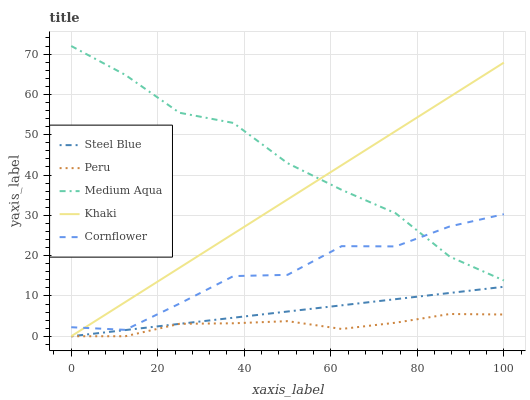Does Peru have the minimum area under the curve?
Answer yes or no. Yes. Does Medium Aqua have the maximum area under the curve?
Answer yes or no. Yes. Does Khaki have the minimum area under the curve?
Answer yes or no. No. Does Khaki have the maximum area under the curve?
Answer yes or no. No. Is Steel Blue the smoothest?
Answer yes or no. Yes. Is Cornflower the roughest?
Answer yes or no. Yes. Is Khaki the smoothest?
Answer yes or no. No. Is Khaki the roughest?
Answer yes or no. No. Does Khaki have the lowest value?
Answer yes or no. Yes. Does Medium Aqua have the lowest value?
Answer yes or no. No. Does Medium Aqua have the highest value?
Answer yes or no. Yes. Does Khaki have the highest value?
Answer yes or no. No. Is Steel Blue less than Cornflower?
Answer yes or no. Yes. Is Medium Aqua greater than Peru?
Answer yes or no. Yes. Does Khaki intersect Steel Blue?
Answer yes or no. Yes. Is Khaki less than Steel Blue?
Answer yes or no. No. Is Khaki greater than Steel Blue?
Answer yes or no. No. Does Steel Blue intersect Cornflower?
Answer yes or no. No. 